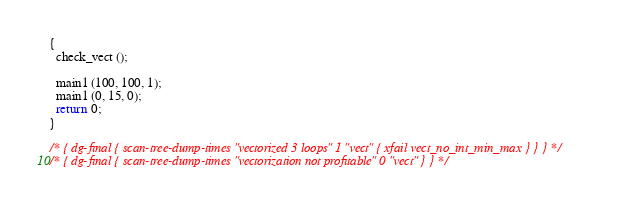<code> <loc_0><loc_0><loc_500><loc_500><_C_>{ 
  check_vect ();
  
  main1 (100, 100, 1);
  main1 (0, 15, 0);
  return 0;
}

/* { dg-final { scan-tree-dump-times "vectorized 3 loops" 1 "vect" { xfail vect_no_int_min_max } } } */
/* { dg-final { scan-tree-dump-times "vectorization not profitable" 0 "vect" } } */
</code> 